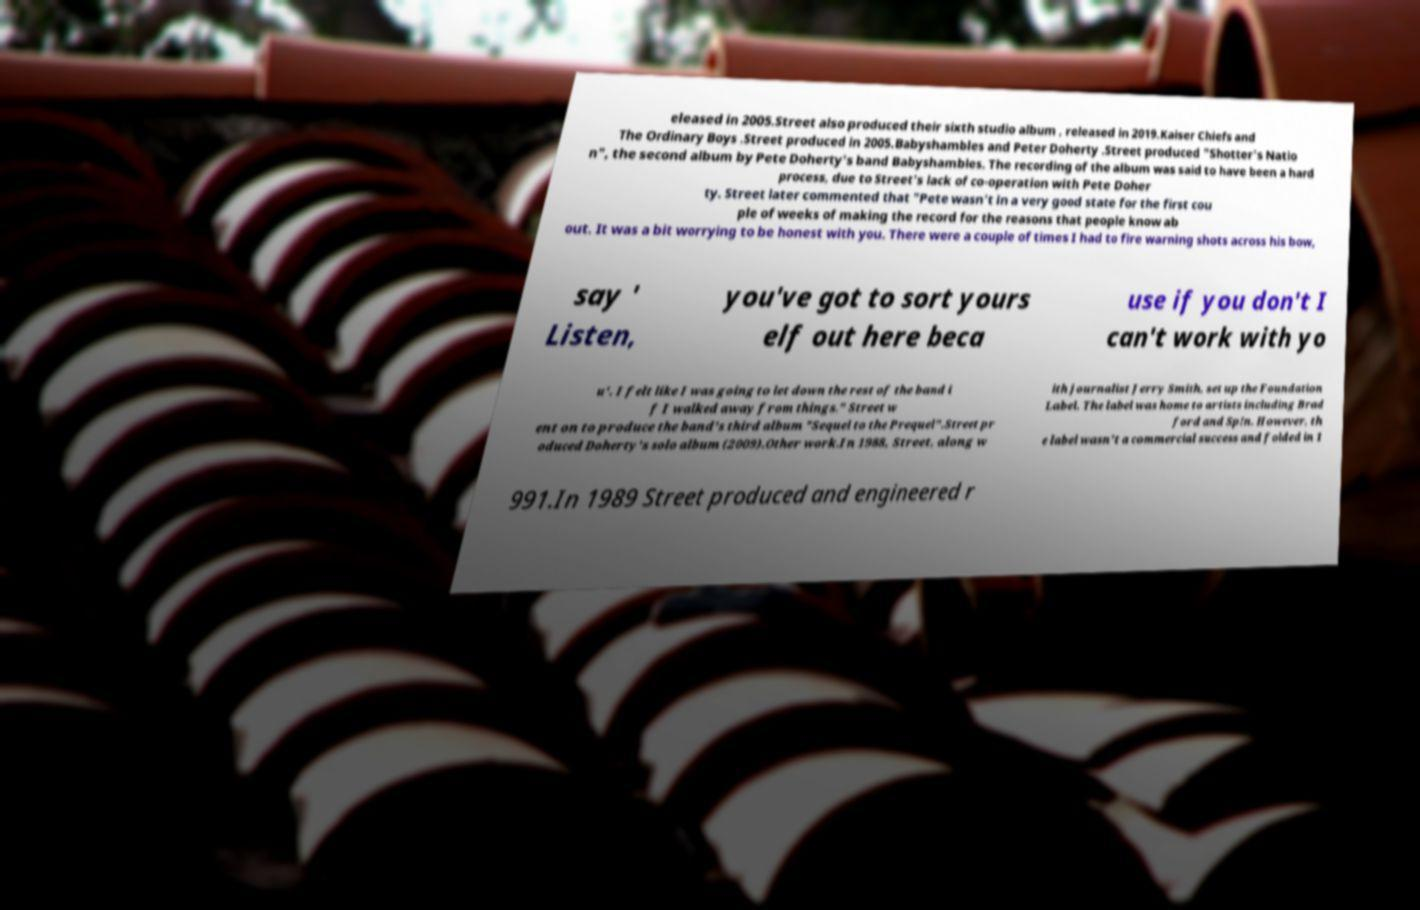For documentation purposes, I need the text within this image transcribed. Could you provide that? eleased in 2005.Street also produced their sixth studio album , released in 2019.Kaiser Chiefs and The Ordinary Boys .Street produced in 2005.Babyshambles and Peter Doherty .Street produced "Shotter's Natio n", the second album by Pete Doherty's band Babyshambles. The recording of the album was said to have been a hard process, due to Street's lack of co-operation with Pete Doher ty. Street later commented that "Pete wasn't in a very good state for the first cou ple of weeks of making the record for the reasons that people know ab out. It was a bit worrying to be honest with you. There were a couple of times I had to fire warning shots across his bow, say ' Listen, you've got to sort yours elf out here beca use if you don't I can't work with yo u'. I felt like I was going to let down the rest of the band i f I walked away from things." Street w ent on to produce the band's third album "Sequel to the Prequel".Street pr oduced Doherty's solo album (2009).Other work.In 1988, Street, along w ith journalist Jerry Smith, set up the Foundation Label. The label was home to artists including Brad ford and Sp!n. However, th e label wasn't a commercial success and folded in 1 991.In 1989 Street produced and engineered r 